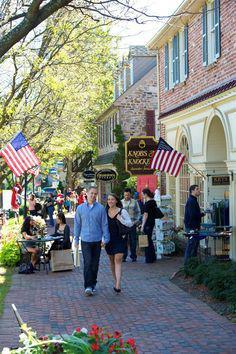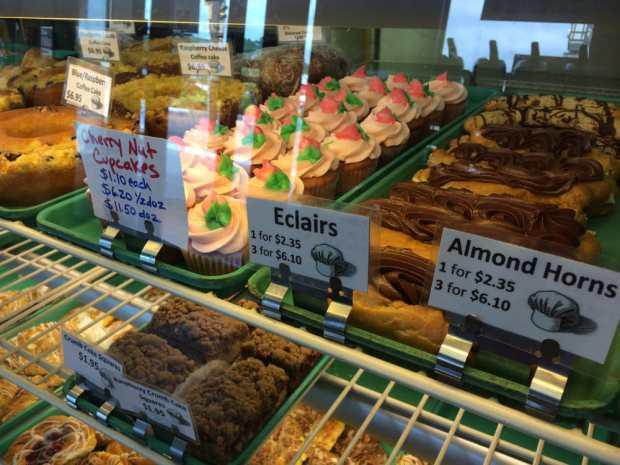The first image is the image on the left, the second image is the image on the right. Assess this claim about the two images: "Two people are standing in front of a food vendor in the image on the left.". Correct or not? Answer yes or no. No. 